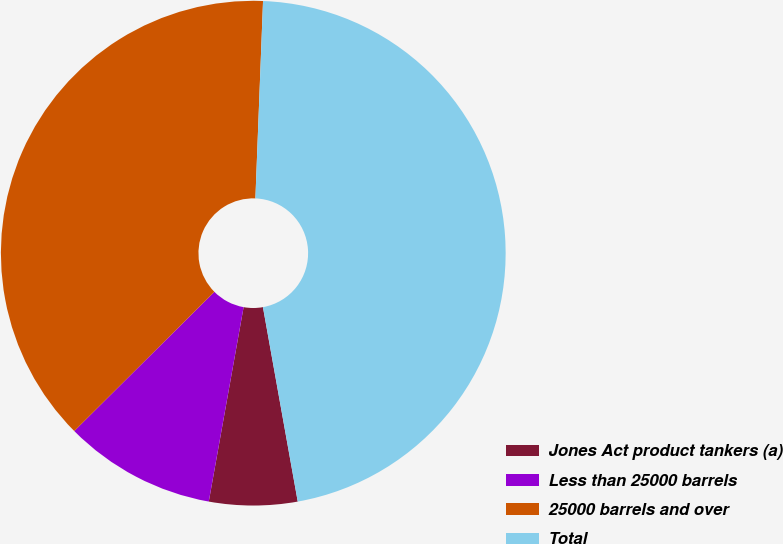Convert chart to OTSL. <chart><loc_0><loc_0><loc_500><loc_500><pie_chart><fcel>Jones Act product tankers (a)<fcel>Less than 25000 barrels<fcel>25000 barrels and over<fcel>Total<nl><fcel>5.64%<fcel>9.73%<fcel>38.06%<fcel>46.56%<nl></chart> 